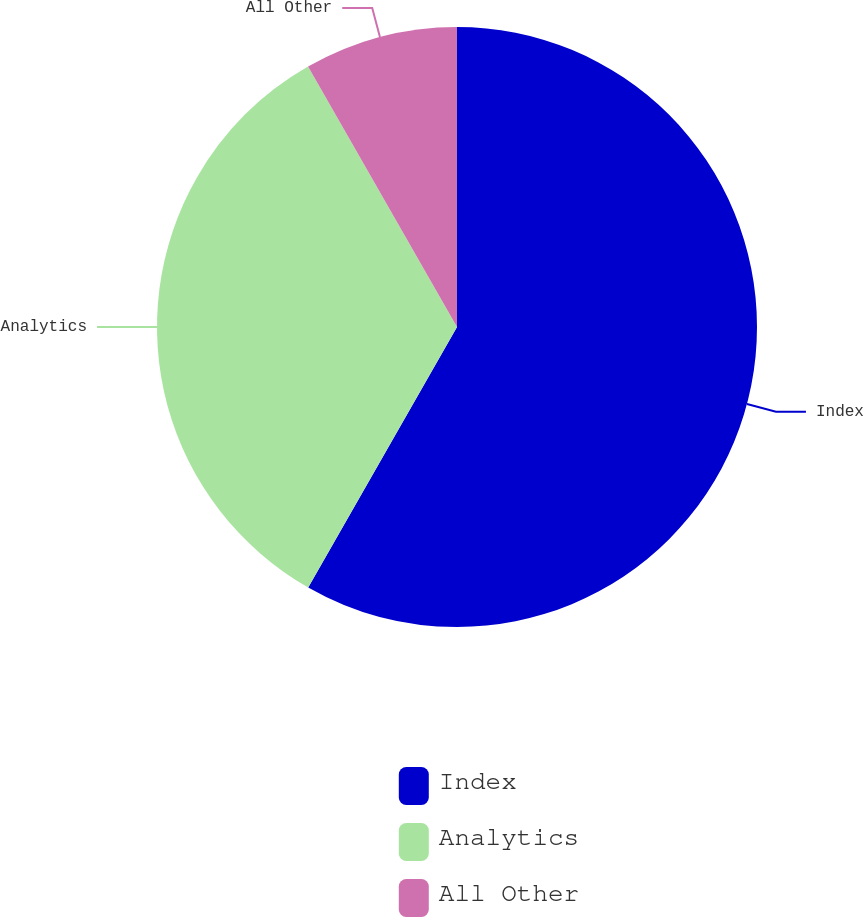Convert chart to OTSL. <chart><loc_0><loc_0><loc_500><loc_500><pie_chart><fcel>Index<fcel>Analytics<fcel>All Other<nl><fcel>58.26%<fcel>33.47%<fcel>8.27%<nl></chart> 